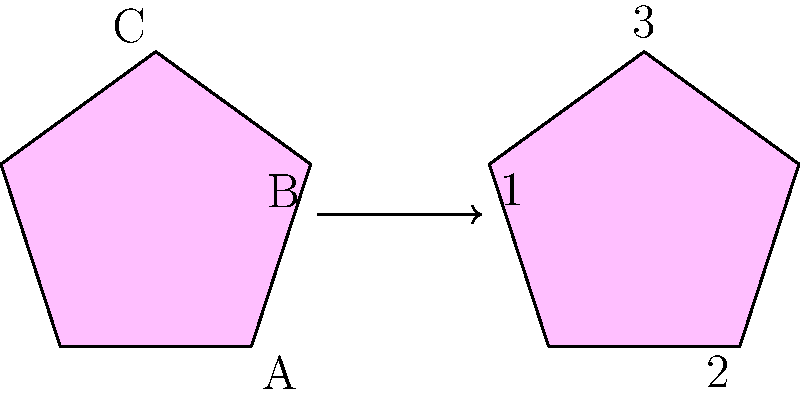As a psychologist studying spatial reasoning in patients with various mental health conditions, you encounter a test item designed to assess spatial intelligence. The figure on the left shows three overlapping pentagons labeled A, B, and C. If this figure is rotated 216° clockwise, which of the numbered pentagons on the right represents the new position of pentagon A? To solve this problem, we need to follow these steps:

1. Understand the initial configuration:
   - Pentagon A is light blue and positioned at the bottom.
   - Pentagon B is light green and positioned at the top right.
   - Pentagon C is pink and positioned at the top left.

2. Visualize the rotation:
   - The entire figure is rotated 216° clockwise.
   - This is equivalent to rotating 144° counterclockwise (360° - 216° = 144°).

3. Analyze the resulting configuration:
   - After rotation, pentagon A (light blue) will move to the top left position.
   - Pentagon B (light green) will move to the bottom position.
   - Pentagon C (pink) will move to the top right position.

4. Compare with the given options:
   - Pentagon 1 is light blue and positioned at the top left.
   - Pentagon 2 is light green and positioned at the bottom.
   - Pentagon 3 is pink and positioned at the top right.

5. Identify the correct answer:
   - Pentagon 1 (light blue, top left) corresponds to the new position of pentagon A after rotation.

This spatial reasoning task requires mental rotation and the ability to track the movement of specific elements within a complex figure, skills often assessed in cognitive evaluations for various mental health conditions.
Answer: 1 